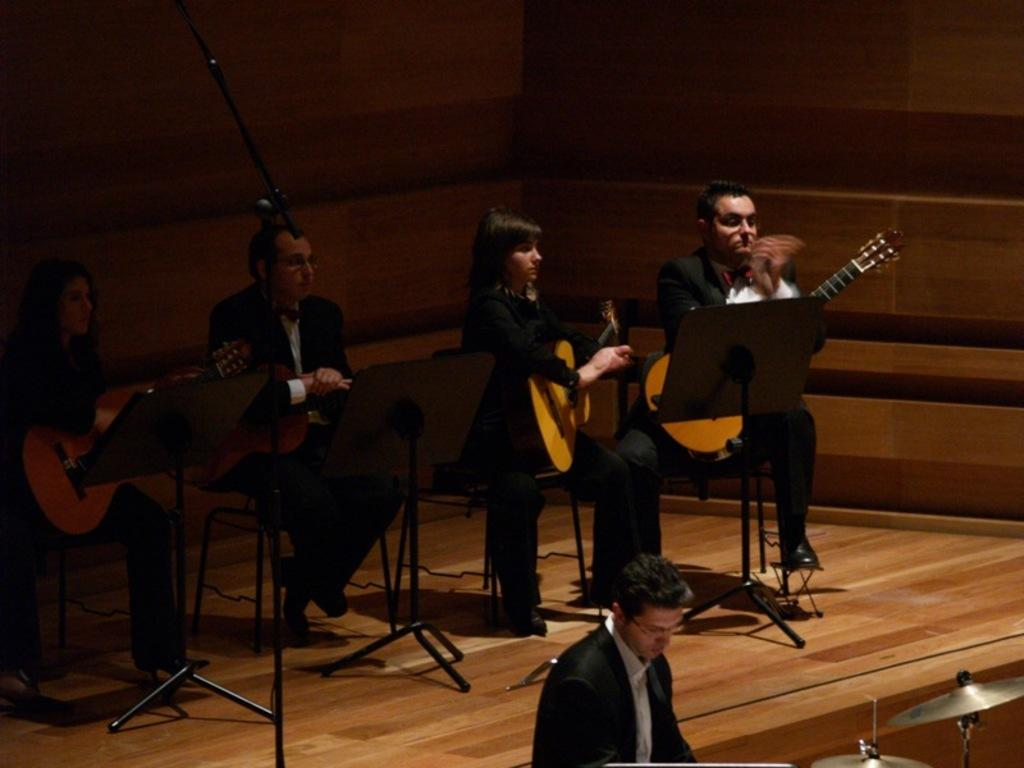What is the lighting condition in the image? The background of the image is dark. What are the persons in the image doing? The persons are sitting on chairs in front of mics and playing guitars. What type of platform is shown in the image? This is a platform. Can you describe the appearance of one of the persons in the image? There is a man wearing spectacles in the image. What other musical instrument can be seen in the image? There are cymbals visible in the image. What type of substance is the beggar holding in the image? There is no beggar present in the image, and therefore no such interaction can be observed. 